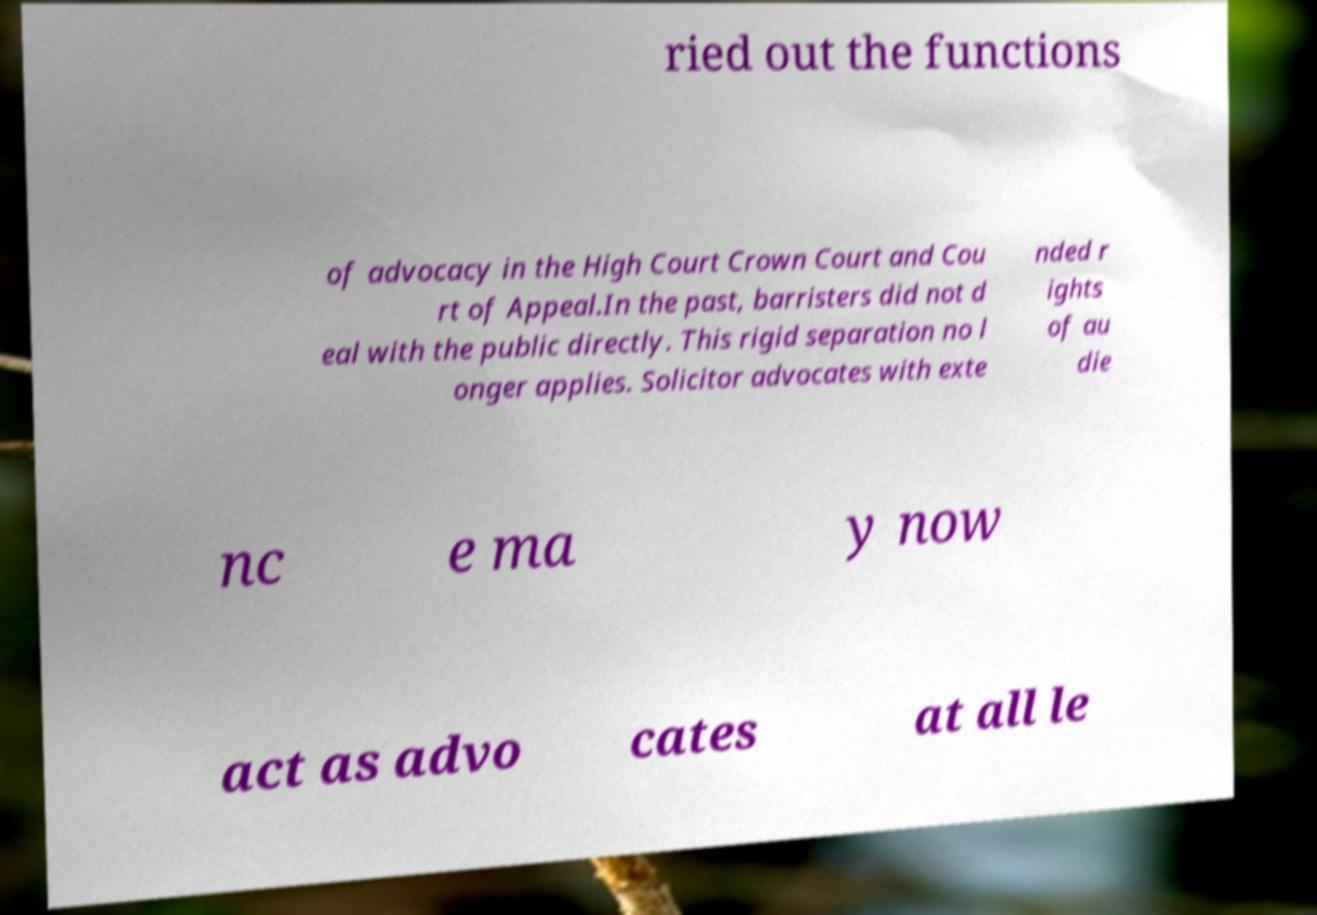Can you accurately transcribe the text from the provided image for me? ried out the functions of advocacy in the High Court Crown Court and Cou rt of Appeal.In the past, barristers did not d eal with the public directly. This rigid separation no l onger applies. Solicitor advocates with exte nded r ights of au die nc e ma y now act as advo cates at all le 